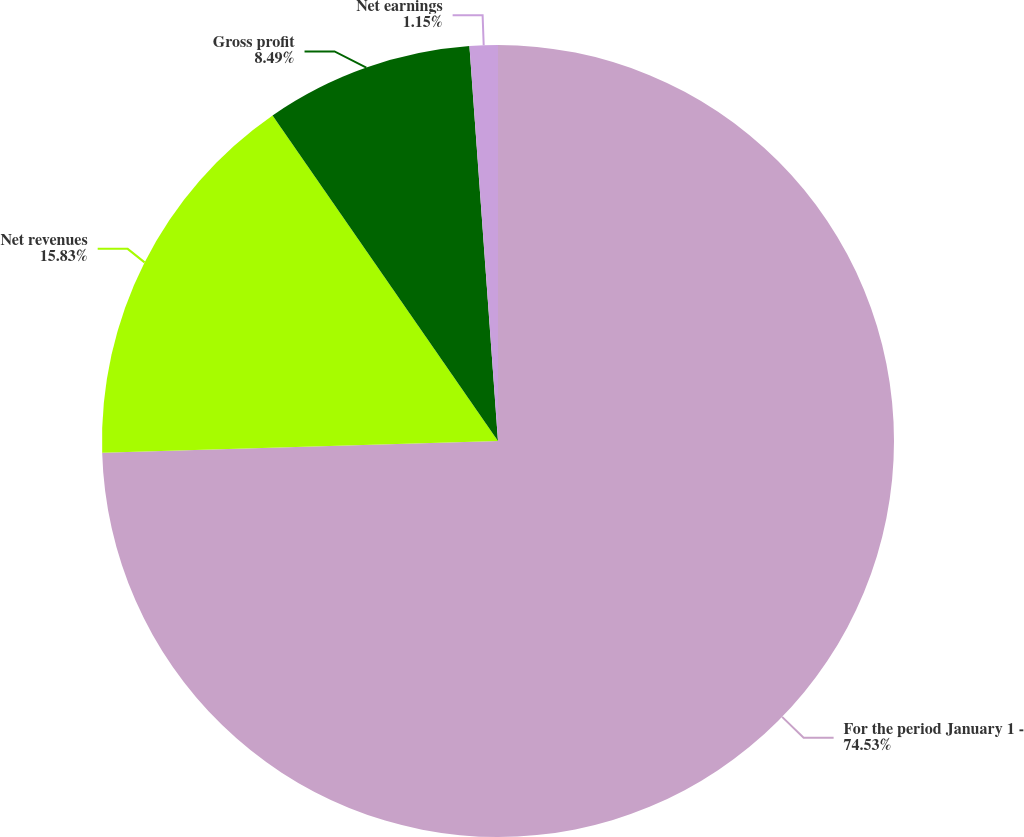Convert chart to OTSL. <chart><loc_0><loc_0><loc_500><loc_500><pie_chart><fcel>For the period January 1 -<fcel>Net revenues<fcel>Gross profit<fcel>Net earnings<nl><fcel>74.54%<fcel>15.83%<fcel>8.49%<fcel>1.15%<nl></chart> 